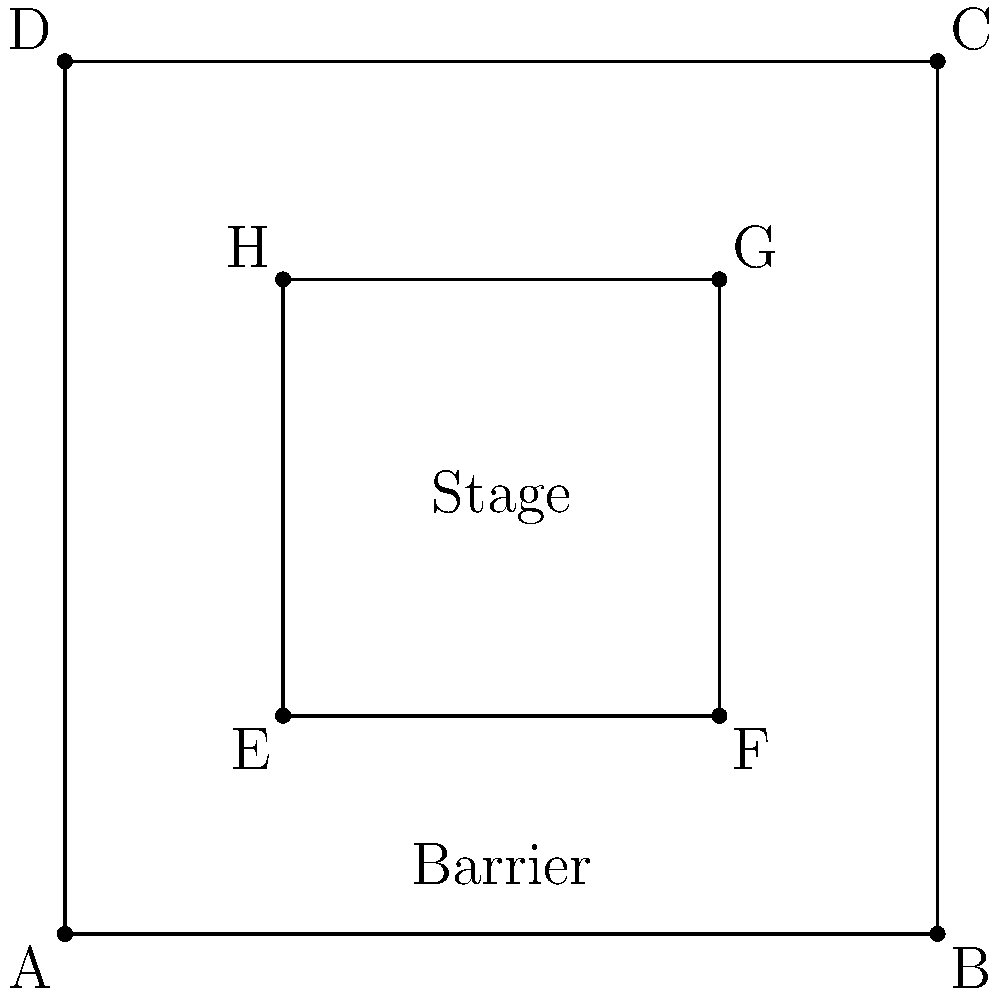Consider the diagram representing a royal stage setup with protective barriers. The outer square ABCD represents the entire area, while the inner square EFGH represents the stage. If the side length of ABCD is 4 units and the side length of EFGH is 2 units, determine if the protective barrier arrangement is congruent when rotated 90°, 180°, and 270° around the center of the stage. What is the minimum rotation angle that results in a congruent arrangement? To determine if the protective barrier arrangement is congruent when rotated, we need to analyze the symmetry of the setup:

1. First, note that the stage (EFGH) is centered within the entire area (ABCD).

2. The distance between the stage and the outer boundary is uniform on all sides:
   - Distance AE = BF = CG = DH = 1 unit

3. Let's consider rotations around the center of the stage:
   - 90° rotation: The arrangement looks identical after a 90° rotation.
   - 180° rotation: The arrangement also looks identical after a 180° rotation.
   - 270° rotation: This is equivalent to a -90° rotation, which we've established looks identical.

4. The fact that the arrangement looks identical after 90° rotations indicates that it has 4-fold rotational symmetry.

5. To find the minimum rotation angle that results in a congruent arrangement, we need to consider the smallest non-zero rotation that produces an identical configuration.

6. Given the 4-fold rotational symmetry, the minimum angle is 360° ÷ 4 = 90°.

Therefore, the protective barrier arrangement is congruent when rotated 90°, 180°, and 270° around the center of the stage, and the minimum rotation angle that results in a congruent arrangement is 90°.
Answer: 90° 